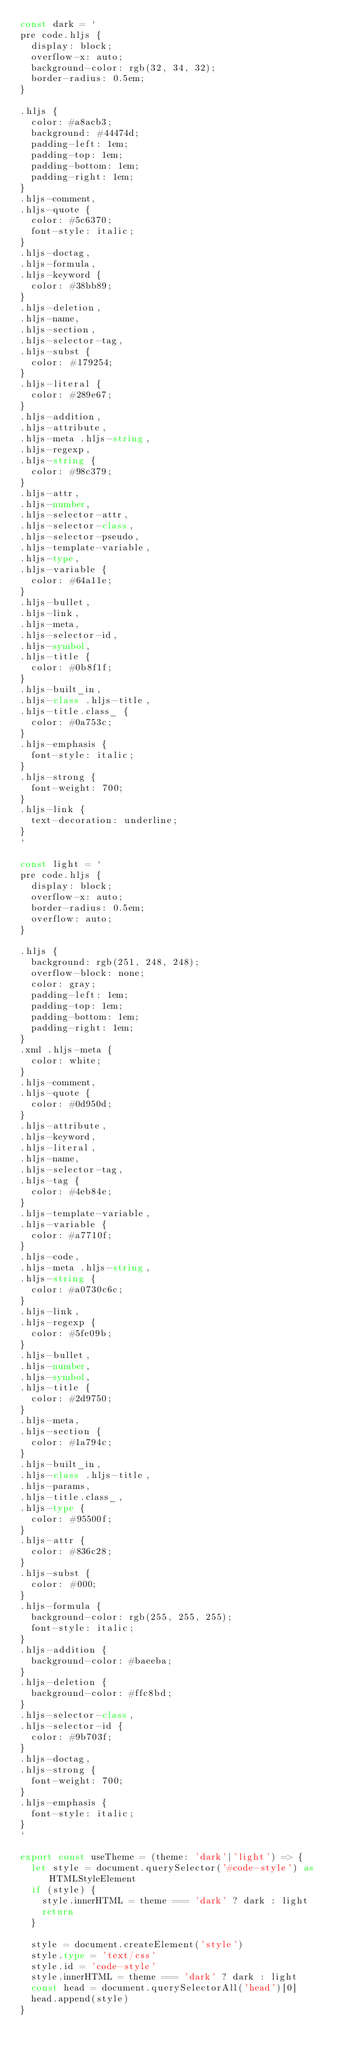Convert code to text. <code><loc_0><loc_0><loc_500><loc_500><_TypeScript_>const dark = `
pre code.hljs {
  display: block;
  overflow-x: auto;
  background-color: rgb(32, 34, 32);
  border-radius: 0.5em;
}

.hljs {
  color: #a8acb3;
  background: #44474d;
  padding-left: 1em;
  padding-top: 1em;
  padding-bottom: 1em;
  padding-right: 1em;
}
.hljs-comment,
.hljs-quote {
  color: #5c6370;
  font-style: italic;
}
.hljs-doctag,
.hljs-formula,
.hljs-keyword {
  color: #38bb89;
}
.hljs-deletion,
.hljs-name,
.hljs-section,
.hljs-selector-tag,
.hljs-subst {
  color: #179254;
}
.hljs-literal {
  color: #289e67;
}
.hljs-addition,
.hljs-attribute,
.hljs-meta .hljs-string,
.hljs-regexp,
.hljs-string {
  color: #98c379;
}
.hljs-attr,
.hljs-number,
.hljs-selector-attr,
.hljs-selector-class,
.hljs-selector-pseudo,
.hljs-template-variable,
.hljs-type,
.hljs-variable {
  color: #64a11e;
}
.hljs-bullet,
.hljs-link,
.hljs-meta,
.hljs-selector-id,
.hljs-symbol,
.hljs-title {
  color: #0b8f1f;
}
.hljs-built_in,
.hljs-class .hljs-title,
.hljs-title.class_ {
  color: #0a753c;
}
.hljs-emphasis {
  font-style: italic;
}
.hljs-strong {
  font-weight: 700;
}
.hljs-link {
  text-decoration: underline;
}
`

const light = `
pre code.hljs {
  display: block;
  overflow-x: auto;
  border-radius: 0.5em;
  overflow: auto;
}

.hljs {
  background: rgb(251, 248, 248);
  overflow-block: none;
  color: gray;
  padding-left: 1em;
  padding-top: 1em;
  padding-bottom: 1em;
  padding-right: 1em;
}
.xml .hljs-meta {
  color: white;
}
.hljs-comment,
.hljs-quote {
  color: #0d950d;
}
.hljs-attribute,
.hljs-keyword,
.hljs-literal,
.hljs-name,
.hljs-selector-tag,
.hljs-tag {
  color: #4eb84e;
}
.hljs-template-variable,
.hljs-variable {
  color: #a7710f;
}
.hljs-code,
.hljs-meta .hljs-string,
.hljs-string {
  color: #a0730c6c;
}
.hljs-link,
.hljs-regexp {
  color: #5fe09b;
}
.hljs-bullet,
.hljs-number,
.hljs-symbol,
.hljs-title {
  color: #2d9750;
}
.hljs-meta,
.hljs-section {
  color: #1a794c;
}
.hljs-built_in,
.hljs-class .hljs-title,
.hljs-params,
.hljs-title.class_,
.hljs-type {
  color: #95500f;
}
.hljs-attr {
  color: #836c28;
}
.hljs-subst {
  color: #000;
}
.hljs-formula {
  background-color: rgb(255, 255, 255);
  font-style: italic;
}
.hljs-addition {
  background-color: #baeeba;
}
.hljs-deletion {
  background-color: #ffc8bd;
}
.hljs-selector-class,
.hljs-selector-id {
  color: #9b703f;
}
.hljs-doctag,
.hljs-strong {
  font-weight: 700;
}
.hljs-emphasis {
  font-style: italic;
}
`

export const useTheme = (theme: 'dark'|'light') => {
  let style = document.querySelector('#code-style') as HTMLStyleElement
  if (style) {
    style.innerHTML = theme === 'dark' ? dark : light
    return
  }

  style = document.createElement('style')
  style.type = 'text/css'
  style.id = 'code-style'
  style.innerHTML = theme === 'dark' ? dark : light
  const head = document.querySelectorAll('head')[0]
  head.append(style)
}
</code> 